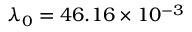<formula> <loc_0><loc_0><loc_500><loc_500>\lambda _ { 0 } = 4 6 . 1 6 \times 1 0 ^ { - 3 }</formula> 